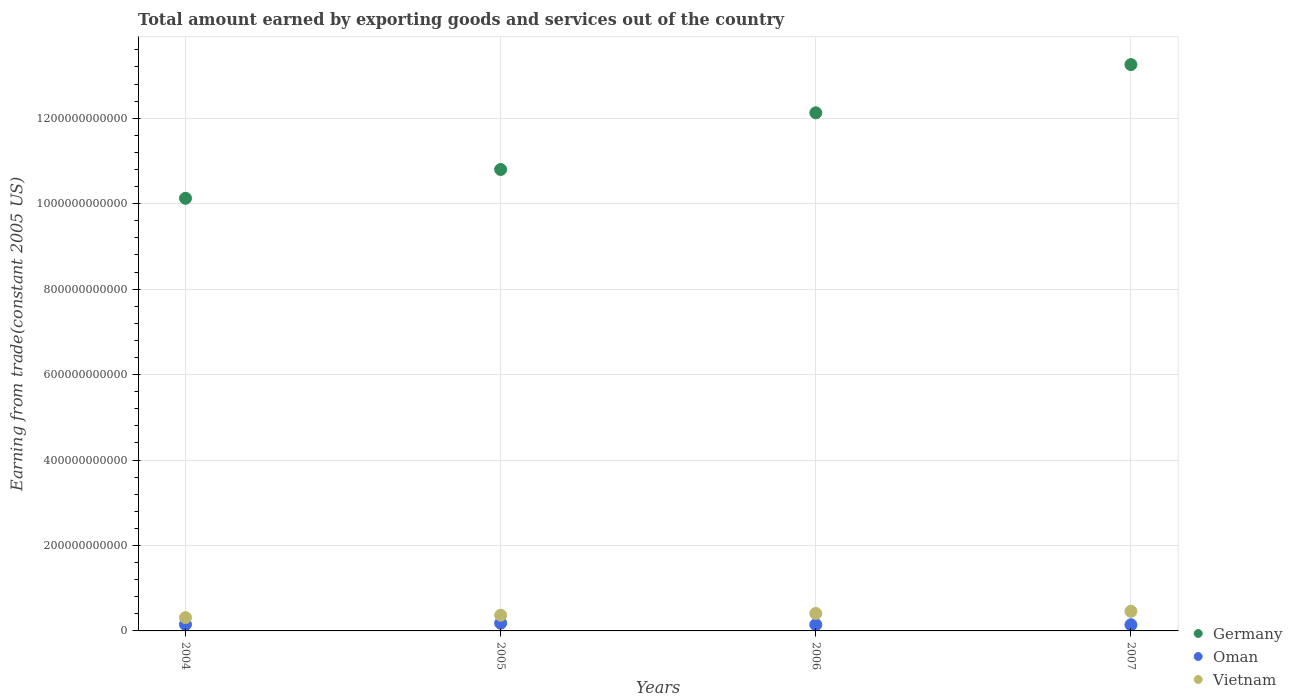Is the number of dotlines equal to the number of legend labels?
Offer a very short reply. Yes. What is the total amount earned by exporting goods and services in Oman in 2007?
Provide a short and direct response. 1.45e+1. Across all years, what is the maximum total amount earned by exporting goods and services in Vietnam?
Your answer should be compact. 4.59e+1. Across all years, what is the minimum total amount earned by exporting goods and services in Oman?
Offer a terse response. 1.45e+1. In which year was the total amount earned by exporting goods and services in Vietnam maximum?
Provide a succinct answer. 2007. In which year was the total amount earned by exporting goods and services in Vietnam minimum?
Make the answer very short. 2004. What is the total total amount earned by exporting goods and services in Germany in the graph?
Your response must be concise. 4.63e+12. What is the difference between the total amount earned by exporting goods and services in Oman in 2005 and that in 2006?
Keep it short and to the point. 3.38e+09. What is the difference between the total amount earned by exporting goods and services in Oman in 2004 and the total amount earned by exporting goods and services in Germany in 2007?
Your answer should be very brief. -1.31e+12. What is the average total amount earned by exporting goods and services in Vietnam per year?
Your answer should be very brief. 3.87e+1. In the year 2007, what is the difference between the total amount earned by exporting goods and services in Oman and total amount earned by exporting goods and services in Vietnam?
Ensure brevity in your answer.  -3.15e+1. What is the ratio of the total amount earned by exporting goods and services in Oman in 2004 to that in 2007?
Ensure brevity in your answer.  1.05. What is the difference between the highest and the second highest total amount earned by exporting goods and services in Oman?
Keep it short and to the point. 2.95e+09. What is the difference between the highest and the lowest total amount earned by exporting goods and services in Oman?
Offer a very short reply. 3.65e+09. Is the sum of the total amount earned by exporting goods and services in Germany in 2004 and 2005 greater than the maximum total amount earned by exporting goods and services in Oman across all years?
Provide a succinct answer. Yes. Does the total amount earned by exporting goods and services in Germany monotonically increase over the years?
Provide a short and direct response. Yes. Is the total amount earned by exporting goods and services in Vietnam strictly greater than the total amount earned by exporting goods and services in Germany over the years?
Your answer should be very brief. No. How many years are there in the graph?
Give a very brief answer. 4. What is the difference between two consecutive major ticks on the Y-axis?
Provide a short and direct response. 2.00e+11. Are the values on the major ticks of Y-axis written in scientific E-notation?
Offer a terse response. No. Does the graph contain any zero values?
Offer a terse response. No. How many legend labels are there?
Your answer should be very brief. 3. How are the legend labels stacked?
Your answer should be compact. Vertical. What is the title of the graph?
Give a very brief answer. Total amount earned by exporting goods and services out of the country. Does "Panama" appear as one of the legend labels in the graph?
Provide a succinct answer. No. What is the label or title of the Y-axis?
Provide a succinct answer. Earning from trade(constant 2005 US). What is the Earning from trade(constant 2005 US) of Germany in 2004?
Your answer should be very brief. 1.01e+12. What is the Earning from trade(constant 2005 US) in Oman in 2004?
Make the answer very short. 1.52e+1. What is the Earning from trade(constant 2005 US) of Vietnam in 2004?
Give a very brief answer. 3.12e+1. What is the Earning from trade(constant 2005 US) of Germany in 2005?
Your response must be concise. 1.08e+12. What is the Earning from trade(constant 2005 US) in Oman in 2005?
Provide a succinct answer. 1.81e+1. What is the Earning from trade(constant 2005 US) of Vietnam in 2005?
Provide a succinct answer. 3.67e+1. What is the Earning from trade(constant 2005 US) of Germany in 2006?
Your response must be concise. 1.21e+12. What is the Earning from trade(constant 2005 US) in Oman in 2006?
Your answer should be compact. 1.47e+1. What is the Earning from trade(constant 2005 US) in Vietnam in 2006?
Offer a very short reply. 4.08e+1. What is the Earning from trade(constant 2005 US) in Germany in 2007?
Your response must be concise. 1.33e+12. What is the Earning from trade(constant 2005 US) in Oman in 2007?
Make the answer very short. 1.45e+1. What is the Earning from trade(constant 2005 US) in Vietnam in 2007?
Offer a very short reply. 4.59e+1. Across all years, what is the maximum Earning from trade(constant 2005 US) in Germany?
Ensure brevity in your answer.  1.33e+12. Across all years, what is the maximum Earning from trade(constant 2005 US) in Oman?
Your answer should be very brief. 1.81e+1. Across all years, what is the maximum Earning from trade(constant 2005 US) in Vietnam?
Give a very brief answer. 4.59e+1. Across all years, what is the minimum Earning from trade(constant 2005 US) of Germany?
Make the answer very short. 1.01e+12. Across all years, what is the minimum Earning from trade(constant 2005 US) in Oman?
Your response must be concise. 1.45e+1. Across all years, what is the minimum Earning from trade(constant 2005 US) in Vietnam?
Your response must be concise. 3.12e+1. What is the total Earning from trade(constant 2005 US) of Germany in the graph?
Provide a short and direct response. 4.63e+12. What is the total Earning from trade(constant 2005 US) in Oman in the graph?
Ensure brevity in your answer.  6.25e+1. What is the total Earning from trade(constant 2005 US) of Vietnam in the graph?
Make the answer very short. 1.55e+11. What is the difference between the Earning from trade(constant 2005 US) in Germany in 2004 and that in 2005?
Keep it short and to the point. -6.74e+1. What is the difference between the Earning from trade(constant 2005 US) in Oman in 2004 and that in 2005?
Offer a terse response. -2.95e+09. What is the difference between the Earning from trade(constant 2005 US) of Vietnam in 2004 and that in 2005?
Provide a succinct answer. -5.54e+09. What is the difference between the Earning from trade(constant 2005 US) in Germany in 2004 and that in 2006?
Offer a very short reply. -2.00e+11. What is the difference between the Earning from trade(constant 2005 US) in Oman in 2004 and that in 2006?
Give a very brief answer. 4.27e+08. What is the difference between the Earning from trade(constant 2005 US) in Vietnam in 2004 and that in 2006?
Ensure brevity in your answer.  -9.65e+09. What is the difference between the Earning from trade(constant 2005 US) of Germany in 2004 and that in 2007?
Provide a succinct answer. -3.13e+11. What is the difference between the Earning from trade(constant 2005 US) in Oman in 2004 and that in 2007?
Your answer should be very brief. 7.04e+08. What is the difference between the Earning from trade(constant 2005 US) in Vietnam in 2004 and that in 2007?
Offer a very short reply. -1.48e+1. What is the difference between the Earning from trade(constant 2005 US) in Germany in 2005 and that in 2006?
Keep it short and to the point. -1.33e+11. What is the difference between the Earning from trade(constant 2005 US) of Oman in 2005 and that in 2006?
Your response must be concise. 3.38e+09. What is the difference between the Earning from trade(constant 2005 US) in Vietnam in 2005 and that in 2006?
Provide a succinct answer. -4.11e+09. What is the difference between the Earning from trade(constant 2005 US) of Germany in 2005 and that in 2007?
Offer a terse response. -2.46e+11. What is the difference between the Earning from trade(constant 2005 US) in Oman in 2005 and that in 2007?
Ensure brevity in your answer.  3.65e+09. What is the difference between the Earning from trade(constant 2005 US) in Vietnam in 2005 and that in 2007?
Make the answer very short. -9.21e+09. What is the difference between the Earning from trade(constant 2005 US) in Germany in 2006 and that in 2007?
Your answer should be compact. -1.13e+11. What is the difference between the Earning from trade(constant 2005 US) of Oman in 2006 and that in 2007?
Your answer should be compact. 2.77e+08. What is the difference between the Earning from trade(constant 2005 US) in Vietnam in 2006 and that in 2007?
Provide a short and direct response. -5.10e+09. What is the difference between the Earning from trade(constant 2005 US) in Germany in 2004 and the Earning from trade(constant 2005 US) in Oman in 2005?
Provide a short and direct response. 9.94e+11. What is the difference between the Earning from trade(constant 2005 US) of Germany in 2004 and the Earning from trade(constant 2005 US) of Vietnam in 2005?
Your answer should be compact. 9.76e+11. What is the difference between the Earning from trade(constant 2005 US) in Oman in 2004 and the Earning from trade(constant 2005 US) in Vietnam in 2005?
Offer a terse response. -2.15e+1. What is the difference between the Earning from trade(constant 2005 US) in Germany in 2004 and the Earning from trade(constant 2005 US) in Oman in 2006?
Keep it short and to the point. 9.98e+11. What is the difference between the Earning from trade(constant 2005 US) in Germany in 2004 and the Earning from trade(constant 2005 US) in Vietnam in 2006?
Provide a succinct answer. 9.72e+11. What is the difference between the Earning from trade(constant 2005 US) of Oman in 2004 and the Earning from trade(constant 2005 US) of Vietnam in 2006?
Your answer should be very brief. -2.57e+1. What is the difference between the Earning from trade(constant 2005 US) of Germany in 2004 and the Earning from trade(constant 2005 US) of Oman in 2007?
Make the answer very short. 9.98e+11. What is the difference between the Earning from trade(constant 2005 US) in Germany in 2004 and the Earning from trade(constant 2005 US) in Vietnam in 2007?
Offer a terse response. 9.67e+11. What is the difference between the Earning from trade(constant 2005 US) in Oman in 2004 and the Earning from trade(constant 2005 US) in Vietnam in 2007?
Your response must be concise. -3.08e+1. What is the difference between the Earning from trade(constant 2005 US) of Germany in 2005 and the Earning from trade(constant 2005 US) of Oman in 2006?
Your response must be concise. 1.07e+12. What is the difference between the Earning from trade(constant 2005 US) in Germany in 2005 and the Earning from trade(constant 2005 US) in Vietnam in 2006?
Provide a succinct answer. 1.04e+12. What is the difference between the Earning from trade(constant 2005 US) of Oman in 2005 and the Earning from trade(constant 2005 US) of Vietnam in 2006?
Your answer should be very brief. -2.27e+1. What is the difference between the Earning from trade(constant 2005 US) in Germany in 2005 and the Earning from trade(constant 2005 US) in Oman in 2007?
Your response must be concise. 1.07e+12. What is the difference between the Earning from trade(constant 2005 US) in Germany in 2005 and the Earning from trade(constant 2005 US) in Vietnam in 2007?
Your answer should be very brief. 1.03e+12. What is the difference between the Earning from trade(constant 2005 US) in Oman in 2005 and the Earning from trade(constant 2005 US) in Vietnam in 2007?
Your answer should be very brief. -2.78e+1. What is the difference between the Earning from trade(constant 2005 US) in Germany in 2006 and the Earning from trade(constant 2005 US) in Oman in 2007?
Your answer should be compact. 1.20e+12. What is the difference between the Earning from trade(constant 2005 US) in Germany in 2006 and the Earning from trade(constant 2005 US) in Vietnam in 2007?
Your answer should be compact. 1.17e+12. What is the difference between the Earning from trade(constant 2005 US) of Oman in 2006 and the Earning from trade(constant 2005 US) of Vietnam in 2007?
Offer a very short reply. -3.12e+1. What is the average Earning from trade(constant 2005 US) of Germany per year?
Your answer should be compact. 1.16e+12. What is the average Earning from trade(constant 2005 US) of Oman per year?
Provide a short and direct response. 1.56e+1. What is the average Earning from trade(constant 2005 US) in Vietnam per year?
Your answer should be very brief. 3.87e+1. In the year 2004, what is the difference between the Earning from trade(constant 2005 US) of Germany and Earning from trade(constant 2005 US) of Oman?
Give a very brief answer. 9.97e+11. In the year 2004, what is the difference between the Earning from trade(constant 2005 US) of Germany and Earning from trade(constant 2005 US) of Vietnam?
Your answer should be very brief. 9.81e+11. In the year 2004, what is the difference between the Earning from trade(constant 2005 US) of Oman and Earning from trade(constant 2005 US) of Vietnam?
Your answer should be compact. -1.60e+1. In the year 2005, what is the difference between the Earning from trade(constant 2005 US) of Germany and Earning from trade(constant 2005 US) of Oman?
Provide a succinct answer. 1.06e+12. In the year 2005, what is the difference between the Earning from trade(constant 2005 US) in Germany and Earning from trade(constant 2005 US) in Vietnam?
Offer a terse response. 1.04e+12. In the year 2005, what is the difference between the Earning from trade(constant 2005 US) of Oman and Earning from trade(constant 2005 US) of Vietnam?
Your response must be concise. -1.86e+1. In the year 2006, what is the difference between the Earning from trade(constant 2005 US) in Germany and Earning from trade(constant 2005 US) in Oman?
Give a very brief answer. 1.20e+12. In the year 2006, what is the difference between the Earning from trade(constant 2005 US) of Germany and Earning from trade(constant 2005 US) of Vietnam?
Provide a short and direct response. 1.17e+12. In the year 2006, what is the difference between the Earning from trade(constant 2005 US) of Oman and Earning from trade(constant 2005 US) of Vietnam?
Provide a succinct answer. -2.61e+1. In the year 2007, what is the difference between the Earning from trade(constant 2005 US) of Germany and Earning from trade(constant 2005 US) of Oman?
Ensure brevity in your answer.  1.31e+12. In the year 2007, what is the difference between the Earning from trade(constant 2005 US) of Germany and Earning from trade(constant 2005 US) of Vietnam?
Keep it short and to the point. 1.28e+12. In the year 2007, what is the difference between the Earning from trade(constant 2005 US) in Oman and Earning from trade(constant 2005 US) in Vietnam?
Offer a very short reply. -3.15e+1. What is the ratio of the Earning from trade(constant 2005 US) of Germany in 2004 to that in 2005?
Your answer should be very brief. 0.94. What is the ratio of the Earning from trade(constant 2005 US) in Oman in 2004 to that in 2005?
Offer a very short reply. 0.84. What is the ratio of the Earning from trade(constant 2005 US) in Vietnam in 2004 to that in 2005?
Your answer should be very brief. 0.85. What is the ratio of the Earning from trade(constant 2005 US) of Germany in 2004 to that in 2006?
Your answer should be compact. 0.83. What is the ratio of the Earning from trade(constant 2005 US) in Vietnam in 2004 to that in 2006?
Ensure brevity in your answer.  0.76. What is the ratio of the Earning from trade(constant 2005 US) of Germany in 2004 to that in 2007?
Ensure brevity in your answer.  0.76. What is the ratio of the Earning from trade(constant 2005 US) of Oman in 2004 to that in 2007?
Keep it short and to the point. 1.05. What is the ratio of the Earning from trade(constant 2005 US) in Vietnam in 2004 to that in 2007?
Offer a terse response. 0.68. What is the ratio of the Earning from trade(constant 2005 US) in Germany in 2005 to that in 2006?
Make the answer very short. 0.89. What is the ratio of the Earning from trade(constant 2005 US) of Oman in 2005 to that in 2006?
Your response must be concise. 1.23. What is the ratio of the Earning from trade(constant 2005 US) of Vietnam in 2005 to that in 2006?
Offer a terse response. 0.9. What is the ratio of the Earning from trade(constant 2005 US) of Germany in 2005 to that in 2007?
Your answer should be very brief. 0.81. What is the ratio of the Earning from trade(constant 2005 US) of Oman in 2005 to that in 2007?
Give a very brief answer. 1.25. What is the ratio of the Earning from trade(constant 2005 US) in Vietnam in 2005 to that in 2007?
Make the answer very short. 0.8. What is the ratio of the Earning from trade(constant 2005 US) in Germany in 2006 to that in 2007?
Ensure brevity in your answer.  0.91. What is the ratio of the Earning from trade(constant 2005 US) of Oman in 2006 to that in 2007?
Give a very brief answer. 1.02. What is the difference between the highest and the second highest Earning from trade(constant 2005 US) in Germany?
Offer a terse response. 1.13e+11. What is the difference between the highest and the second highest Earning from trade(constant 2005 US) of Oman?
Your response must be concise. 2.95e+09. What is the difference between the highest and the second highest Earning from trade(constant 2005 US) of Vietnam?
Give a very brief answer. 5.10e+09. What is the difference between the highest and the lowest Earning from trade(constant 2005 US) in Germany?
Provide a short and direct response. 3.13e+11. What is the difference between the highest and the lowest Earning from trade(constant 2005 US) in Oman?
Make the answer very short. 3.65e+09. What is the difference between the highest and the lowest Earning from trade(constant 2005 US) in Vietnam?
Ensure brevity in your answer.  1.48e+1. 